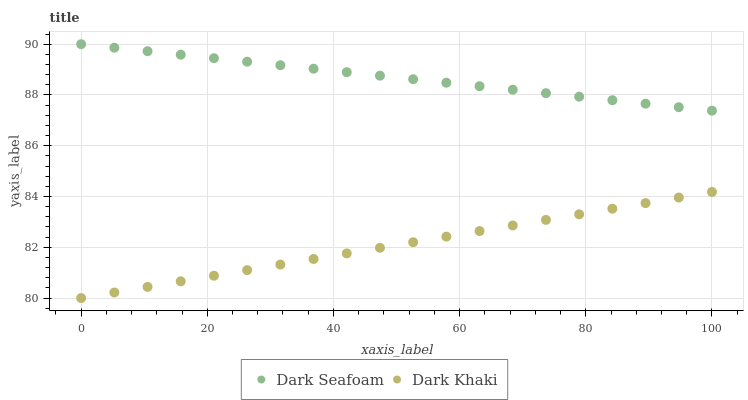Does Dark Khaki have the minimum area under the curve?
Answer yes or no. Yes. Does Dark Seafoam have the maximum area under the curve?
Answer yes or no. Yes. Does Dark Seafoam have the minimum area under the curve?
Answer yes or no. No. Is Dark Khaki the smoothest?
Answer yes or no. Yes. Is Dark Seafoam the roughest?
Answer yes or no. Yes. Is Dark Seafoam the smoothest?
Answer yes or no. No. Does Dark Khaki have the lowest value?
Answer yes or no. Yes. Does Dark Seafoam have the lowest value?
Answer yes or no. No. Does Dark Seafoam have the highest value?
Answer yes or no. Yes. Is Dark Khaki less than Dark Seafoam?
Answer yes or no. Yes. Is Dark Seafoam greater than Dark Khaki?
Answer yes or no. Yes. Does Dark Khaki intersect Dark Seafoam?
Answer yes or no. No. 